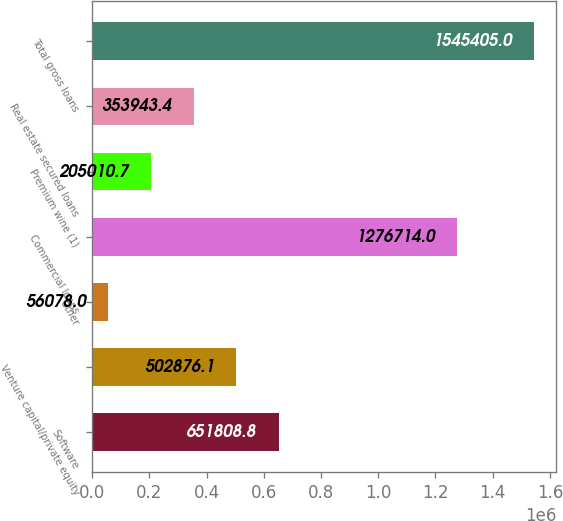<chart> <loc_0><loc_0><loc_500><loc_500><bar_chart><fcel>Software<fcel>Venture capital/private equity<fcel>Other<fcel>Commercial loans<fcel>Premium wine (1)<fcel>Real estate secured loans<fcel>Total gross loans<nl><fcel>651809<fcel>502876<fcel>56078<fcel>1.27671e+06<fcel>205011<fcel>353943<fcel>1.5454e+06<nl></chart> 